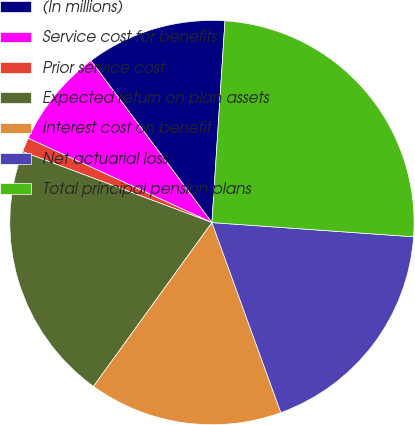Convert chart to OTSL. <chart><loc_0><loc_0><loc_500><loc_500><pie_chart><fcel>(In millions)<fcel>Service cost for benefits<fcel>Prior service cost<fcel>Expected return on plan assets<fcel>Interest cost on benefit<fcel>Net actuarial loss<fcel>Total principal pension plans<nl><fcel>11.24%<fcel>7.94%<fcel>1.14%<fcel>20.74%<fcel>15.5%<fcel>18.34%<fcel>25.09%<nl></chart> 